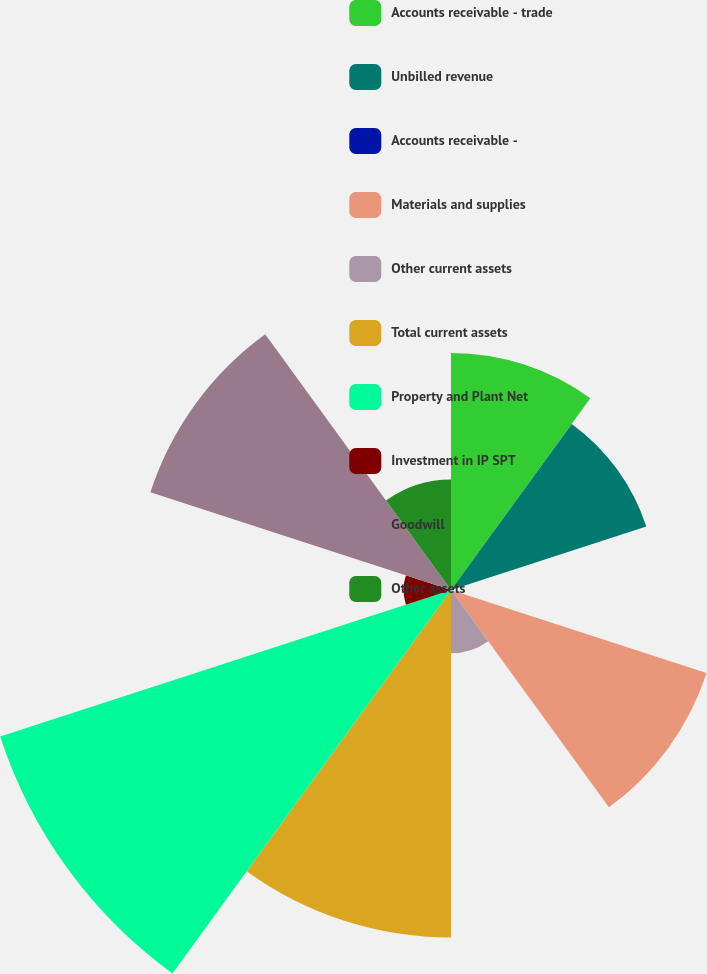<chart> <loc_0><loc_0><loc_500><loc_500><pie_chart><fcel>Accounts receivable - trade<fcel>Unbilled revenue<fcel>Accounts receivable -<fcel>Materials and supplies<fcel>Other current assets<fcel>Total current assets<fcel>Property and Plant Net<fcel>Investment in IP SPT<fcel>Goodwill<fcel>Other assets<nl><fcel>11.45%<fcel>9.92%<fcel>0.0%<fcel>12.98%<fcel>3.06%<fcel>16.79%<fcel>22.9%<fcel>2.29%<fcel>15.27%<fcel>5.34%<nl></chart> 